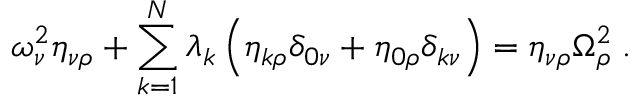Convert formula to latex. <formula><loc_0><loc_0><loc_500><loc_500>\omega _ { \nu } ^ { 2 } \eta _ { \nu \rho } + \sum _ { k = 1 } ^ { N } \lambda _ { k } \left ( \eta _ { k \rho } \delta _ { 0 \nu } + \eta _ { 0 \rho } \delta _ { k \nu } \right ) = \eta _ { \nu \rho } \Omega _ { \rho } ^ { 2 } \, .</formula> 